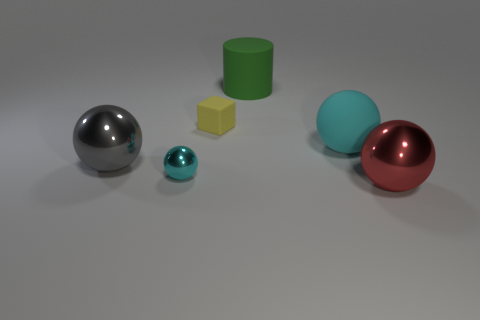What color is the large metal ball behind the red metallic ball?
Ensure brevity in your answer.  Gray. What color is the sphere that is the same size as the yellow rubber cube?
Offer a terse response. Cyan. Is the size of the yellow thing the same as the gray metal ball?
Give a very brief answer. No. How many big gray objects are behind the big cyan object?
Provide a short and direct response. 0. What number of objects are either objects to the left of the matte ball or small rubber things?
Provide a short and direct response. 4. Are there more large gray metal things that are behind the big gray metal ball than large matte cylinders that are behind the large green thing?
Offer a terse response. No. There is a matte ball that is the same color as the small metallic sphere; what size is it?
Offer a very short reply. Large. There is a green thing; is it the same size as the ball in front of the small cyan object?
Give a very brief answer. Yes. How many cylinders are either cyan things or small cyan rubber objects?
Your answer should be compact. 0. What is the size of the red object that is made of the same material as the gray object?
Provide a succinct answer. Large. 